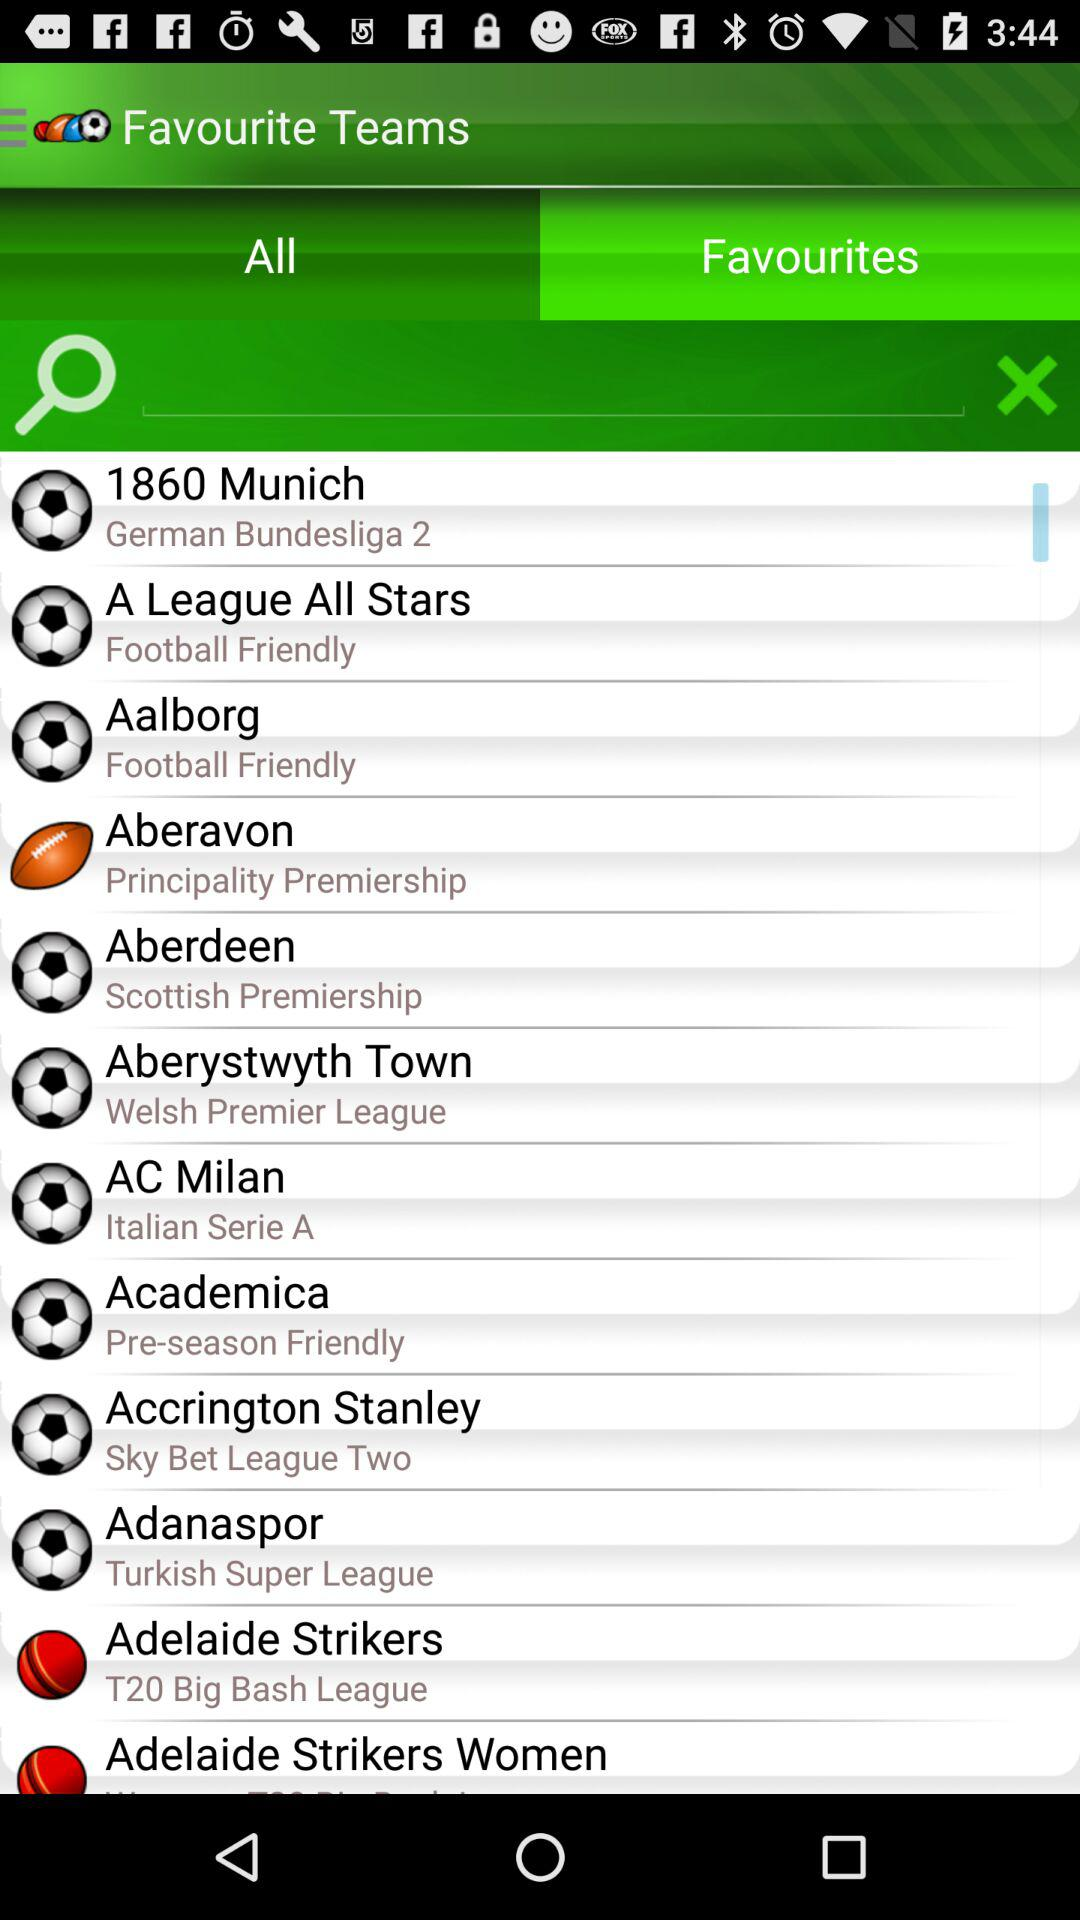Which option is selected? The selected option is "Favourites". 